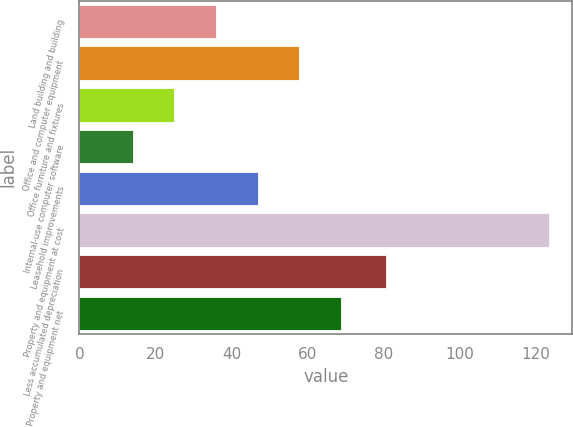Convert chart. <chart><loc_0><loc_0><loc_500><loc_500><bar_chart><fcel>Land building and building<fcel>Office and computer equipment<fcel>Office furniture and fixtures<fcel>Internal-use computer software<fcel>Leasehold improvements<fcel>Property and equipment at cost<fcel>Less accumulated depreciation<fcel>Property and equipment net<nl><fcel>35.88<fcel>57.76<fcel>24.94<fcel>14<fcel>46.82<fcel>123.4<fcel>80.5<fcel>68.7<nl></chart> 